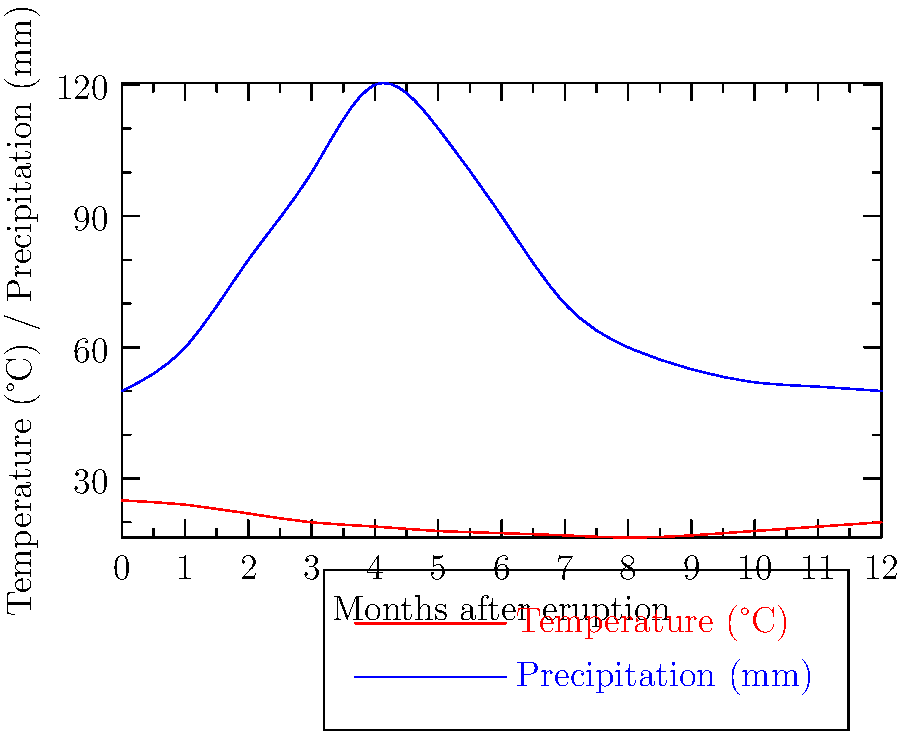Analyze the time-series graphs showing temperature and precipitation changes following a major volcanic eruption. What is the approximate time lag between the minimum temperature and the peak precipitation, and what atmospheric process might explain this relationship? To answer this question, we need to follow these steps:

1. Identify the minimum temperature point:
   - The temperature curve (red) reaches its lowest point at approximately 7-8 months after the eruption.

2. Identify the peak precipitation point:
   - The precipitation curve (blue) reaches its highest point at approximately 4-5 months after the eruption.

3. Calculate the time lag:
   - Time lag = Time of minimum temperature - Time of peak precipitation
   - Time lag ≈ (7.5 months) - (4.5 months) = 3 months

4. Explain the atmospheric process:
   - Volcanic eruptions inject aerosols into the stratosphere, which reflect incoming solar radiation and cool the Earth's surface.
   - As the atmosphere cools, it can hold less water vapor (following the Clausius-Clapeyron relation).
   - Initially, this leads to increased precipitation as the excess water vapor condenses.
   - However, as the cooling continues, the total amount of water vapor in the atmosphere decreases, eventually leading to reduced precipitation.
   - The time lag between peak precipitation and minimum temperature represents the period it takes for the atmosphere to transition from the initial water vapor condensation phase to the overall drier state caused by the prolonged cooling effect.

This process demonstrates the complex interplay between temperature and precipitation following a major volcanic eruption, highlighting the importance of understanding these relationships in climate science and meteorology.
Answer: Approximately 3 months; aerosol-induced cooling and atmospheric water vapor capacity changes. 